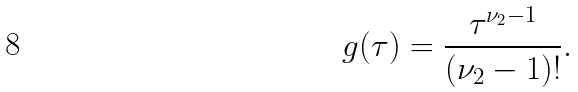Convert formula to latex. <formula><loc_0><loc_0><loc_500><loc_500>g ( \tau ) = \frac { \tau ^ { \nu _ { 2 } - 1 } } { ( \nu _ { 2 } - 1 ) ! } .</formula> 